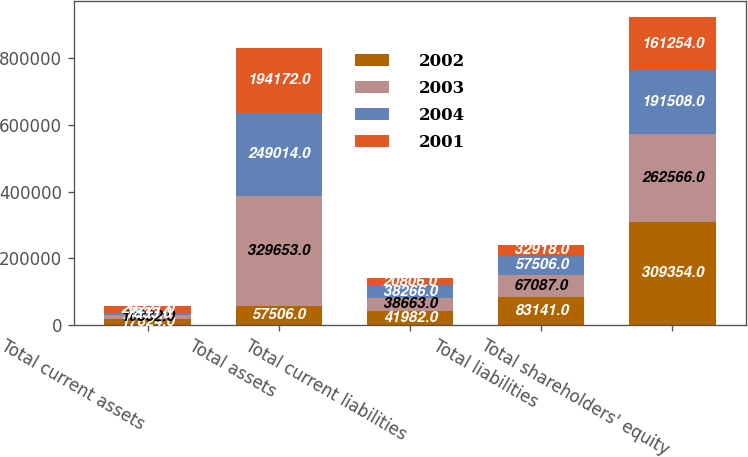Convert chart. <chart><loc_0><loc_0><loc_500><loc_500><stacked_bar_chart><ecel><fcel>Total current assets<fcel>Total assets<fcel>Total current liabilities<fcel>Total liabilities<fcel>Total shareholders' equity<nl><fcel>2002<fcel>17824<fcel>57506<fcel>41982<fcel>83141<fcel>309354<nl><fcel>2003<fcel>10332<fcel>329653<fcel>38663<fcel>67087<fcel>262566<nl><fcel>2004<fcel>7833<fcel>249014<fcel>38266<fcel>57506<fcel>191508<nl><fcel>2001<fcel>20221<fcel>194172<fcel>20806<fcel>32918<fcel>161254<nl></chart> 